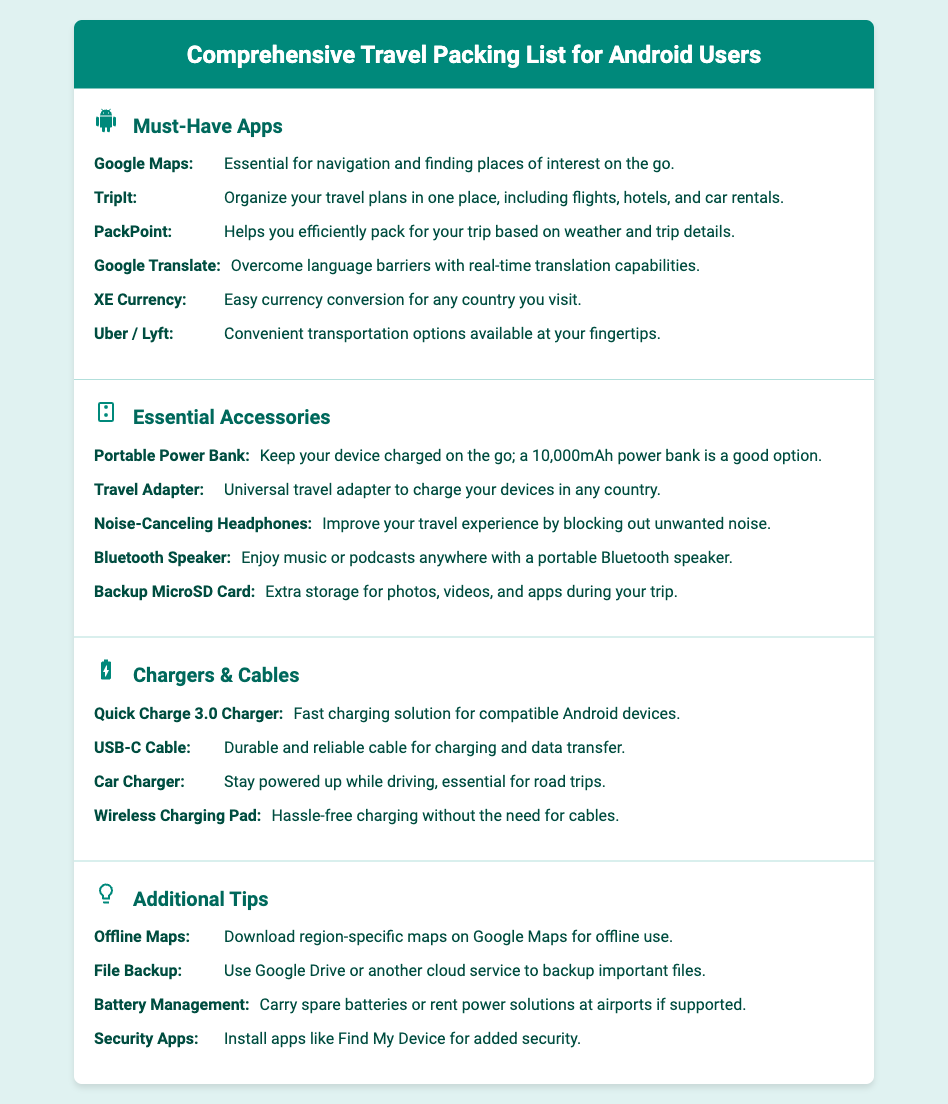What is the title of the document? The title is specified in the heading at the top of the document.
Answer: Comprehensive Travel Packing List for Android Users How many must-have apps are listed? The number of apps is determined by counting the items under the Must-Have Apps section.
Answer: 6 What is the description of the app "PackPoint"? The description provides information about what the app does, specifically in the context of packing.
Answer: Helps you efficiently pack for your trip based on weather and trip details Which accessory is recommended for improved travel experience? This accessory is mentioned under the Essential Accessories section for its noise-canceling capabilities.
Answer: Noise-Canceling Headphones What type of charger is mentioned for fast charging? The charger is specifically noted for its fast charging features in the Chargers & Cables section.
Answer: Quick Charge 3.0 Charger How many additional tips are provided? The total number of tips can be counted under the Additional Tips section.
Answer: 4 What app helps overcome language barriers? The app's name is mentioned as a tool for translation in the Must-Have Apps section.
Answer: Google Translate What is the function of a backup microSD card? The function is outlined in the description under Essential Accessories.
Answer: Extra storage for photos, videos, and apps during your trip 